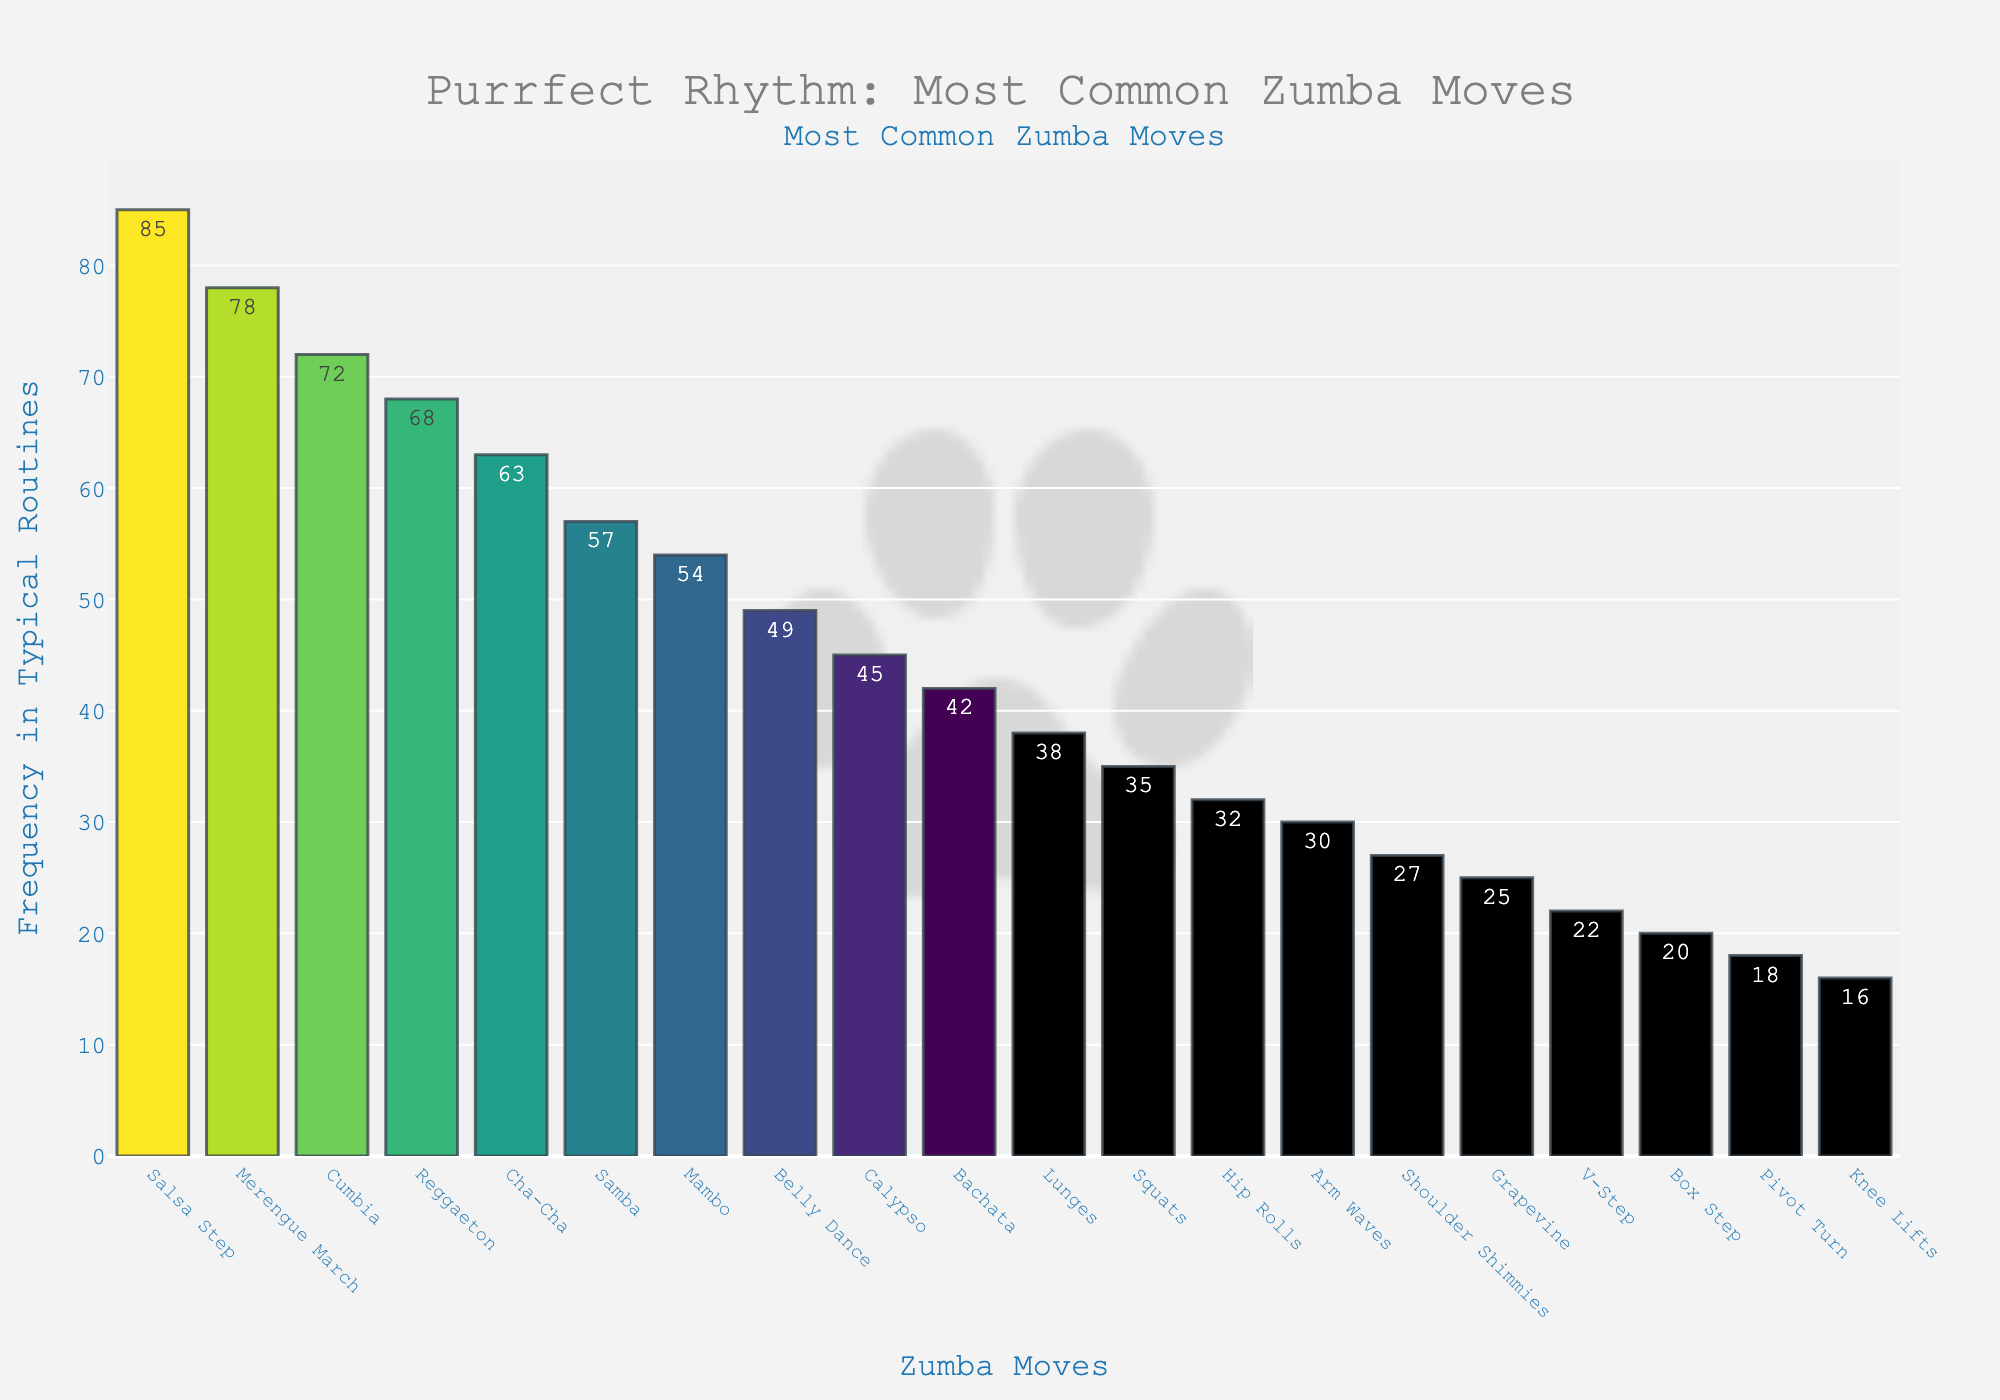What's the most common Zumba move? The move with the highest frequency is "Salsa Step" with a frequency of 85, which is the tallest bar on the plot.
Answer: Salsa Step Which Zumba move appears less frequently, Cha-Cha or Samba? By comparing the heights of the bars for Cha-Cha and Samba, Cha-Cha has a frequency of 63, while Samba has a frequency of 57.
Answer: Samba What’s the sum of frequencies for the top 3 most common Zumba moves? The top three moves are Salsa Step, Merengue March, and Cumbia with frequencies of 85, 78, and 72 respectively. Summing them gives 85 + 78 + 72 = 235.
Answer: 235 How much more frequent is Reggaeton compared to Box Step? The frequency of Reggaeton is 68, while Box Step is 20. The difference is 68 - 20 = 48.
Answer: 48 Which move has a higher frequency: Mambo or Belly Dance? Comparing the bars for Mambo and Belly Dance, Mambo has a frequency of 54 while Belly Dance has 49.
Answer: Mambo What’s the average frequency of Salsa Step, Merengue March, and Cumbia? The frequencies are 85, 78, and 72 respectively. The average is (85 + 78 + 72) / 3 = 235 / 3 = 78.33.
Answer: 78.33 Which move is exactly in the middle in terms of frequency among the listed moves? To find the median, the frequencies need to be listed in ascending order, then select the middle value. The middle frequency in the sorted list is 42 (Bachata).
Answer: Bachata How many moves have a frequency greater than 50? Moves with frequencies greater than 50 are Salsa Step, Merengue March, Cumbia, Reggaeton, Cha-Cha, Samba, and Mambo, which totals to 7 moves.
Answer: 7 Is the frequency of Lunges more than twice the frequency of Arm Waves? The frequency of Lunges is 38, and Arm Waves is 30. Twice the frequency of Arm Waves is 30 * 2 = 60, which is greater than 38.
Answer: No If the frequencies of Salsa Step and Merengue March are combined, what percentage of the total do they represent? The combined frequency is 85 + 78 = 163. The total frequency sum is 847. The percentage is (163 / 847) * 100 ≈ 19.24%.
Answer: 19.24% 